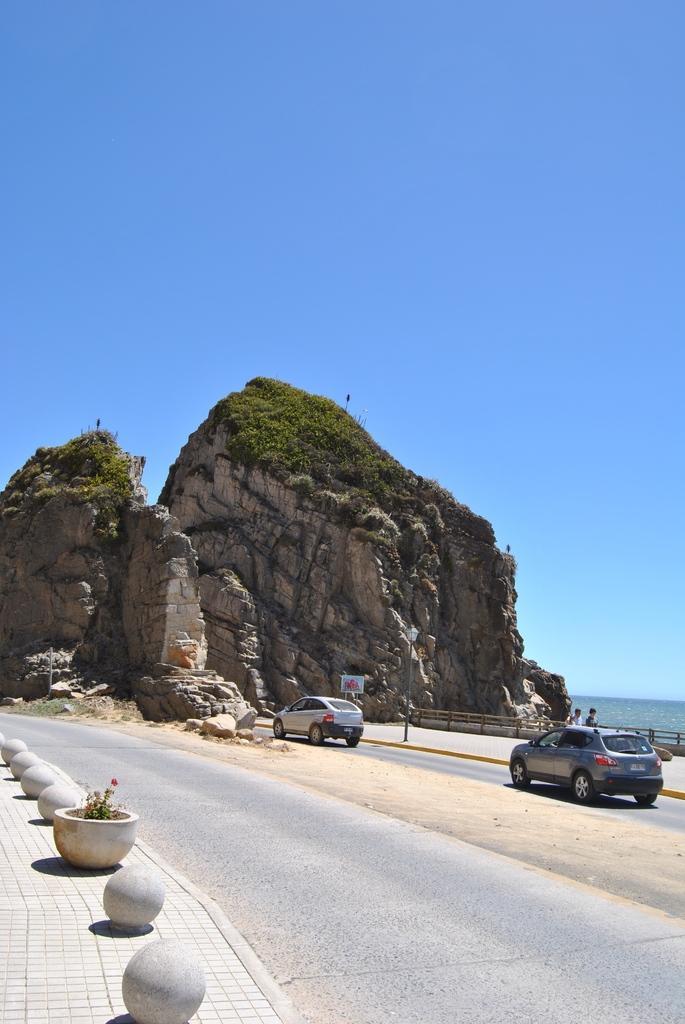Describe this image in one or two sentences. In this image at the center there are two cars on the road. On the left side of the image there is a flower pot and on the right side of the image there is a fence. In the background there are rocks with the grass on it. At the right side of the image there is water and at the top there is the sky. 